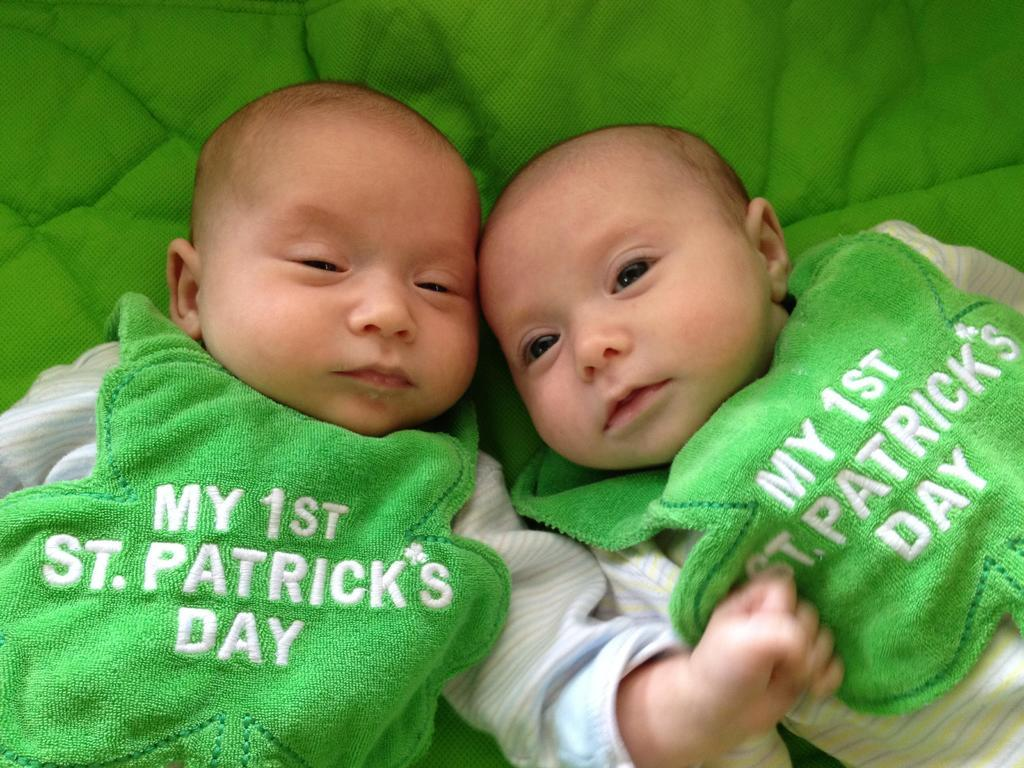What is the main subject of the image? There are two babies in the center of the image. Can you describe the background of the image? There is a green cloth in the background of the image. What type of wood can be seen in the image? There is no wood present in the image; it features two babies and a green cloth in the background. How many fingers are visible on the babies in the image? The image does not show the babies' fingers, so it cannot be determined from the picture. 